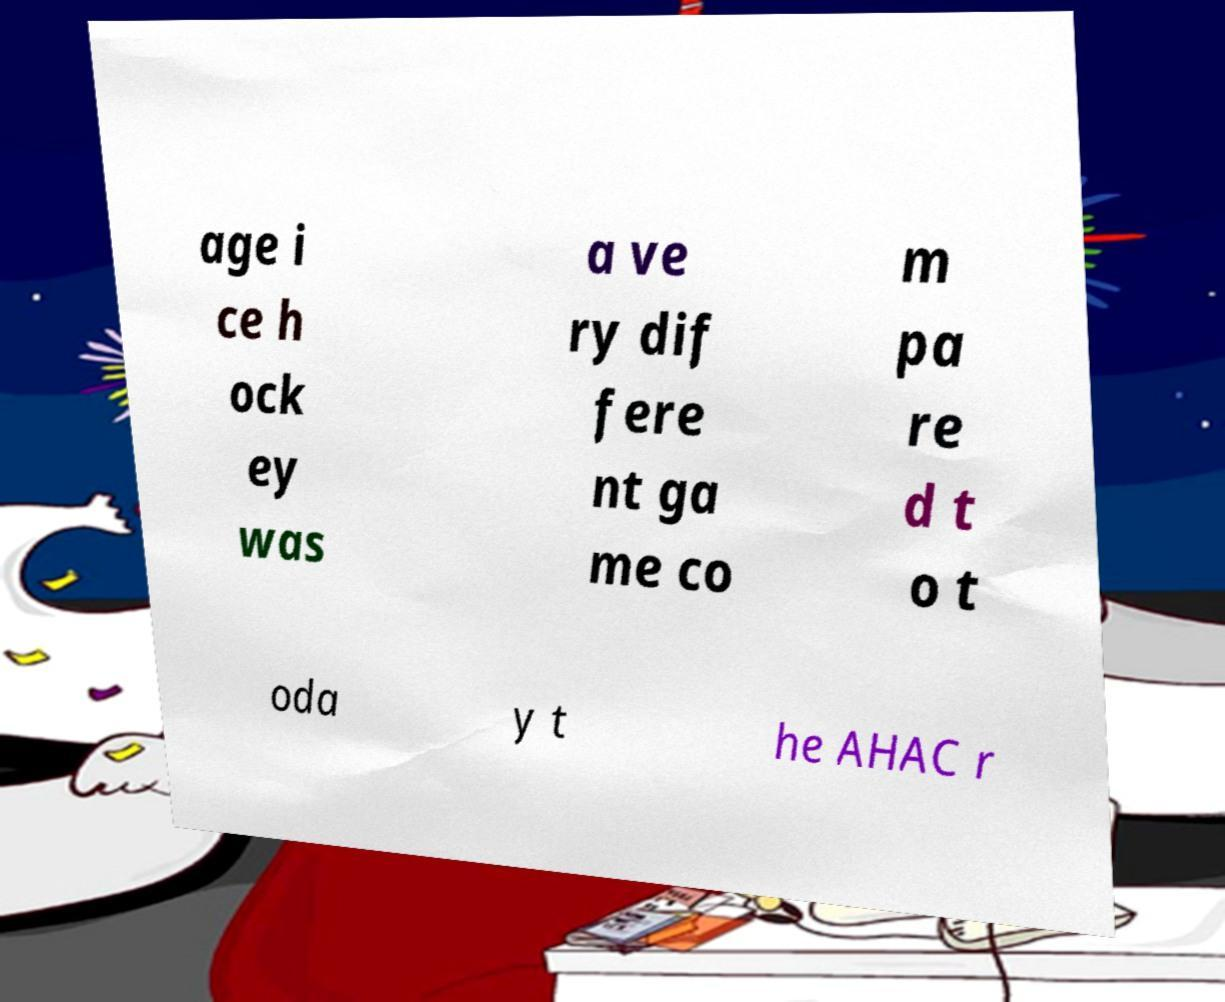I need the written content from this picture converted into text. Can you do that? age i ce h ock ey was a ve ry dif fere nt ga me co m pa re d t o t oda y t he AHAC r 